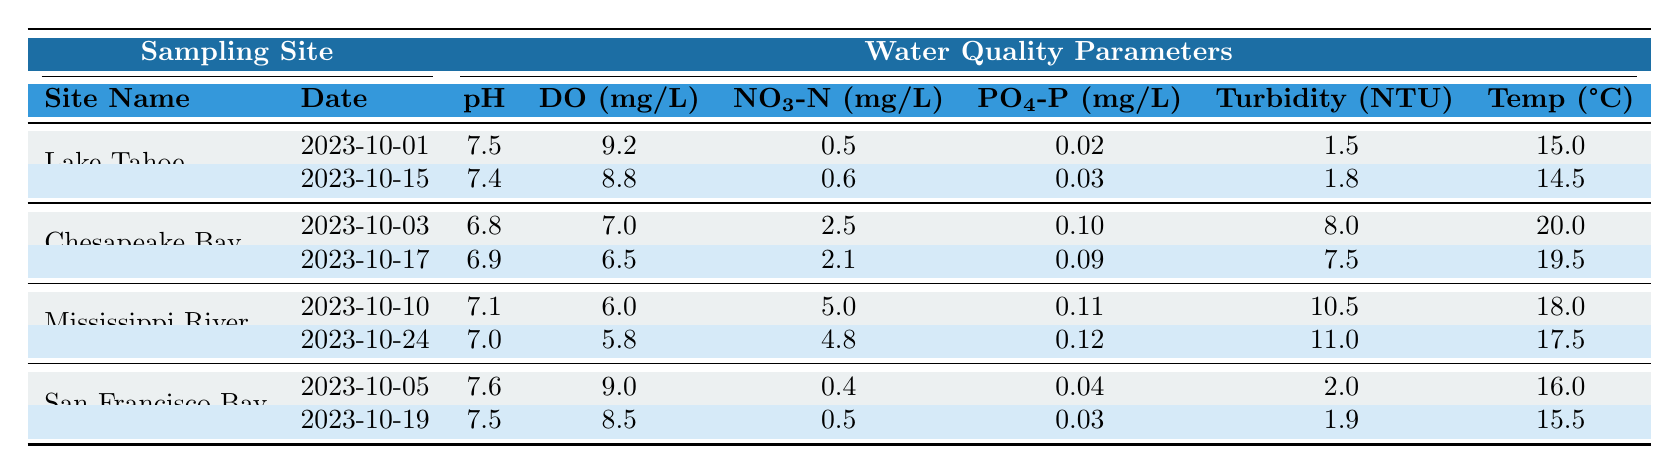What is the pH value recorded at Lake Tahoe on 2023-10-01? The table shows the pH value for Lake Tahoe on the date 2023-10-01 to be 7.5.
Answer: 7.5 What is the highest Turbidity value recorded across the sampling sites? The Turbidity values are 1.5, 1.8, 8.0, 7.5, 10.5, 11.0, 2.0, and 1.9. The highest value is 11.0 from the Mississippi River on 2023-10-24.
Answer: 11.0 Was the Dissolved Oxygen level lower at Chesapeake Bay on 2023-10-17 compared to the level on 2023-10-03? The Dissolved Oxygen on 2023-10-03 is 7.0 mg/L and on 2023-10-17 is 6.5 mg/L. Since 6.5 is less than 7.0, it is true that the level is lower.
Answer: Yes What is the average Nitrate concentration for the sampling dates that occurred in October 2023? The Nitrate concentrations are 0.5, 0.6, 2.5, 2.1, 5.0, 4.8, 0.4, and 0.5. Summing them yields 16.0 mg/L, and there are 8 samples, so 16.0/8 = 2.0 mg/L.
Answer: 2.0 Which site shows the highest recorded temperature? The table shows the temperatures: 15.0, 14.5, 20.0, 19.5, 18.0, 17.5, 16.0, and 15.5. The maximum is 20.0 from Chesapeake Bay on 2023-10-03.
Answer: 20.0 What was the difference in phosphate concentration between the Mississippi River on 2023-10-10 and San Francisco Bay on 2023-10-05? The phosphate concentrations are 0.11 mg/L for the Mississippi River and 0.04 mg/L for San Francisco Bay. The difference is 0.11 - 0.04 = 0.07 mg/L.
Answer: 0.07 Is the average pH lower at Lake Tahoe than at San Francisco Bay? The average pH at Lake Tahoe is (7.5 + 7.4)/2 = 7.45, and at San Francisco Bay is (7.6 + 7.5)/2 = 7.55. Since 7.45 is less than 7.55, it is true that Lake Tahoe's average pH is lower.
Answer: Yes How many sampling dates recorded a dissolved oxygen level above 8 mg/L? The dissolved oxygen levels above 8 mg/L are 9.2 at Lake Tahoe (10-01), 9.0 at San Francisco Bay (10-05), and 8.8 at Lake Tahoe (10-15). That gives us three dates.
Answer: 3 What is the combined Nitrate concentration for all samples at Chesapeake Bay? The Nitrate concentrations for Chesapeake Bay are 2.5 and 2.1. Summing these gives 2.5 + 2.1 = 4.6 mg/L.
Answer: 4.6 Which location had the lowest average temperature between its sampling dates? The temperatures are 15.0, 14.5 for Lake Tahoe, 20.0, 19.5 for Chesapeake Bay, 18.0, 17.5 for Mississippi River, and 16.0, 15.5 for San Francisco Bay. The averages are 14.75, 19.75, 17.75, and 15.75, respectively. The lowest average is at Lake Tahoe.
Answer: Lake Tahoe 